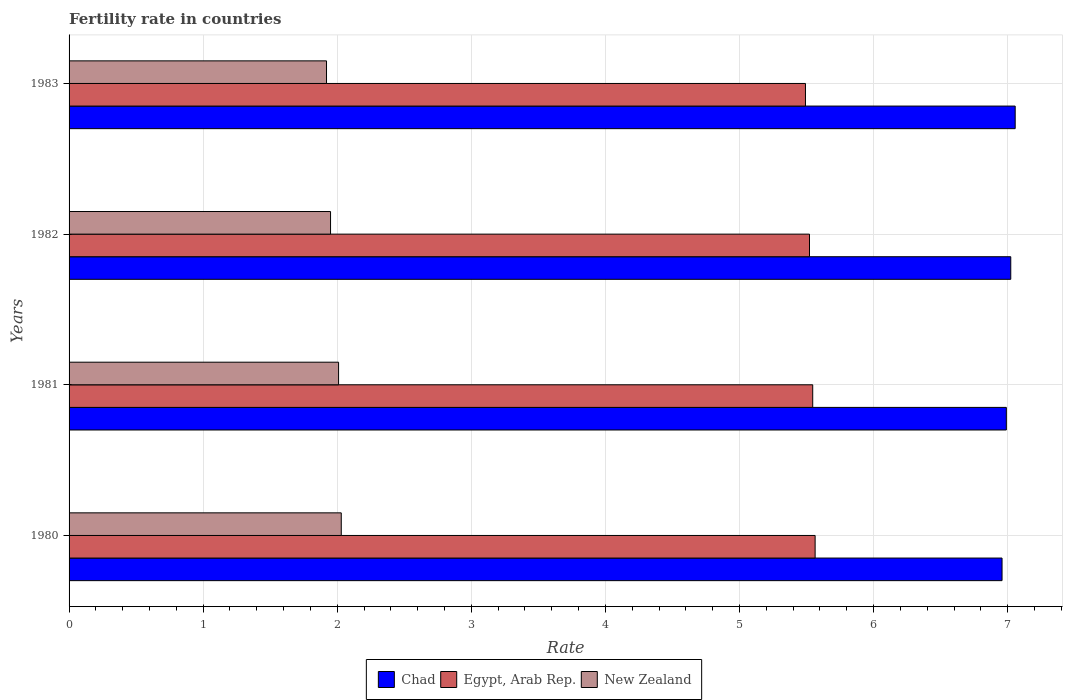How many different coloured bars are there?
Offer a very short reply. 3. How many groups of bars are there?
Offer a terse response. 4. Are the number of bars on each tick of the Y-axis equal?
Provide a short and direct response. Yes. What is the label of the 2nd group of bars from the top?
Your response must be concise. 1982. In how many cases, is the number of bars for a given year not equal to the number of legend labels?
Your answer should be very brief. 0. What is the fertility rate in New Zealand in 1981?
Make the answer very short. 2.01. Across all years, what is the maximum fertility rate in Egypt, Arab Rep.?
Your response must be concise. 5.56. Across all years, what is the minimum fertility rate in New Zealand?
Offer a terse response. 1.92. In which year was the fertility rate in Chad minimum?
Your answer should be very brief. 1980. What is the total fertility rate in Egypt, Arab Rep. in the graph?
Offer a very short reply. 22.12. What is the difference between the fertility rate in Chad in 1980 and that in 1981?
Offer a very short reply. -0.03. What is the difference between the fertility rate in New Zealand in 1981 and the fertility rate in Chad in 1982?
Make the answer very short. -5.01. What is the average fertility rate in New Zealand per year?
Ensure brevity in your answer.  1.98. In the year 1981, what is the difference between the fertility rate in Egypt, Arab Rep. and fertility rate in New Zealand?
Give a very brief answer. 3.54. What is the ratio of the fertility rate in New Zealand in 1982 to that in 1983?
Provide a short and direct response. 1.02. What is the difference between the highest and the second highest fertility rate in Chad?
Provide a succinct answer. 0.03. What is the difference between the highest and the lowest fertility rate in New Zealand?
Ensure brevity in your answer.  0.11. In how many years, is the fertility rate in Egypt, Arab Rep. greater than the average fertility rate in Egypt, Arab Rep. taken over all years?
Your answer should be very brief. 2. What does the 1st bar from the top in 1980 represents?
Provide a succinct answer. New Zealand. What does the 2nd bar from the bottom in 1980 represents?
Your response must be concise. Egypt, Arab Rep. Is it the case that in every year, the sum of the fertility rate in Chad and fertility rate in New Zealand is greater than the fertility rate in Egypt, Arab Rep.?
Your answer should be very brief. Yes. How many years are there in the graph?
Provide a succinct answer. 4. Does the graph contain grids?
Your answer should be compact. Yes. Where does the legend appear in the graph?
Your answer should be very brief. Bottom center. How many legend labels are there?
Give a very brief answer. 3. How are the legend labels stacked?
Ensure brevity in your answer.  Horizontal. What is the title of the graph?
Make the answer very short. Fertility rate in countries. Does "Latin America(developing only)" appear as one of the legend labels in the graph?
Provide a short and direct response. No. What is the label or title of the X-axis?
Your answer should be compact. Rate. What is the label or title of the Y-axis?
Provide a short and direct response. Years. What is the Rate of Chad in 1980?
Your answer should be compact. 6.96. What is the Rate in Egypt, Arab Rep. in 1980?
Offer a terse response. 5.56. What is the Rate of New Zealand in 1980?
Ensure brevity in your answer.  2.03. What is the Rate in Chad in 1981?
Offer a very short reply. 6.99. What is the Rate of Egypt, Arab Rep. in 1981?
Offer a very short reply. 5.55. What is the Rate in New Zealand in 1981?
Provide a short and direct response. 2.01. What is the Rate of Chad in 1982?
Your response must be concise. 7.02. What is the Rate of Egypt, Arab Rep. in 1982?
Keep it short and to the point. 5.52. What is the Rate of New Zealand in 1982?
Provide a succinct answer. 1.95. What is the Rate of Chad in 1983?
Provide a succinct answer. 7.06. What is the Rate of Egypt, Arab Rep. in 1983?
Your answer should be very brief. 5.49. What is the Rate in New Zealand in 1983?
Your response must be concise. 1.92. Across all years, what is the maximum Rate in Chad?
Provide a succinct answer. 7.06. Across all years, what is the maximum Rate in Egypt, Arab Rep.?
Offer a very short reply. 5.56. Across all years, what is the maximum Rate of New Zealand?
Your answer should be compact. 2.03. Across all years, what is the minimum Rate in Chad?
Make the answer very short. 6.96. Across all years, what is the minimum Rate of Egypt, Arab Rep.?
Your answer should be very brief. 5.49. Across all years, what is the minimum Rate in New Zealand?
Give a very brief answer. 1.92. What is the total Rate in Chad in the graph?
Make the answer very short. 28.03. What is the total Rate in Egypt, Arab Rep. in the graph?
Provide a short and direct response. 22.12. What is the total Rate in New Zealand in the graph?
Offer a very short reply. 7.91. What is the difference between the Rate of Chad in 1980 and that in 1981?
Your answer should be compact. -0.03. What is the difference between the Rate of Egypt, Arab Rep. in 1980 and that in 1981?
Provide a succinct answer. 0.02. What is the difference between the Rate in Chad in 1980 and that in 1982?
Give a very brief answer. -0.07. What is the difference between the Rate of Egypt, Arab Rep. in 1980 and that in 1982?
Your response must be concise. 0.04. What is the difference between the Rate in Chad in 1980 and that in 1983?
Provide a succinct answer. -0.1. What is the difference between the Rate of Egypt, Arab Rep. in 1980 and that in 1983?
Your response must be concise. 0.07. What is the difference between the Rate of New Zealand in 1980 and that in 1983?
Give a very brief answer. 0.11. What is the difference between the Rate in Chad in 1981 and that in 1982?
Your answer should be very brief. -0.03. What is the difference between the Rate in Egypt, Arab Rep. in 1981 and that in 1982?
Ensure brevity in your answer.  0.02. What is the difference between the Rate of Chad in 1981 and that in 1983?
Offer a terse response. -0.07. What is the difference between the Rate of Egypt, Arab Rep. in 1981 and that in 1983?
Your answer should be very brief. 0.05. What is the difference between the Rate of New Zealand in 1981 and that in 1983?
Offer a terse response. 0.09. What is the difference between the Rate in Chad in 1982 and that in 1983?
Your response must be concise. -0.03. What is the difference between the Rate in Egypt, Arab Rep. in 1982 and that in 1983?
Your answer should be very brief. 0.03. What is the difference between the Rate in New Zealand in 1982 and that in 1983?
Provide a short and direct response. 0.03. What is the difference between the Rate in Chad in 1980 and the Rate in Egypt, Arab Rep. in 1981?
Offer a terse response. 1.41. What is the difference between the Rate of Chad in 1980 and the Rate of New Zealand in 1981?
Offer a very short reply. 4.95. What is the difference between the Rate of Egypt, Arab Rep. in 1980 and the Rate of New Zealand in 1981?
Ensure brevity in your answer.  3.55. What is the difference between the Rate in Chad in 1980 and the Rate in Egypt, Arab Rep. in 1982?
Your answer should be very brief. 1.44. What is the difference between the Rate of Chad in 1980 and the Rate of New Zealand in 1982?
Give a very brief answer. 5.01. What is the difference between the Rate of Egypt, Arab Rep. in 1980 and the Rate of New Zealand in 1982?
Offer a very short reply. 3.61. What is the difference between the Rate in Chad in 1980 and the Rate in Egypt, Arab Rep. in 1983?
Offer a very short reply. 1.47. What is the difference between the Rate of Chad in 1980 and the Rate of New Zealand in 1983?
Your answer should be compact. 5.04. What is the difference between the Rate in Egypt, Arab Rep. in 1980 and the Rate in New Zealand in 1983?
Give a very brief answer. 3.64. What is the difference between the Rate in Chad in 1981 and the Rate in Egypt, Arab Rep. in 1982?
Offer a very short reply. 1.47. What is the difference between the Rate in Chad in 1981 and the Rate in New Zealand in 1982?
Offer a terse response. 5.04. What is the difference between the Rate in Egypt, Arab Rep. in 1981 and the Rate in New Zealand in 1982?
Keep it short and to the point. 3.6. What is the difference between the Rate of Chad in 1981 and the Rate of Egypt, Arab Rep. in 1983?
Offer a very short reply. 1.5. What is the difference between the Rate in Chad in 1981 and the Rate in New Zealand in 1983?
Provide a succinct answer. 5.07. What is the difference between the Rate in Egypt, Arab Rep. in 1981 and the Rate in New Zealand in 1983?
Offer a very short reply. 3.63. What is the difference between the Rate in Chad in 1982 and the Rate in Egypt, Arab Rep. in 1983?
Your answer should be compact. 1.53. What is the difference between the Rate of Chad in 1982 and the Rate of New Zealand in 1983?
Provide a succinct answer. 5.1. What is the difference between the Rate of Egypt, Arab Rep. in 1982 and the Rate of New Zealand in 1983?
Your answer should be compact. 3.6. What is the average Rate of Chad per year?
Offer a very short reply. 7.01. What is the average Rate in Egypt, Arab Rep. per year?
Ensure brevity in your answer.  5.53. What is the average Rate of New Zealand per year?
Ensure brevity in your answer.  1.98. In the year 1980, what is the difference between the Rate in Chad and Rate in Egypt, Arab Rep.?
Provide a succinct answer. 1.39. In the year 1980, what is the difference between the Rate of Chad and Rate of New Zealand?
Make the answer very short. 4.93. In the year 1980, what is the difference between the Rate of Egypt, Arab Rep. and Rate of New Zealand?
Provide a short and direct response. 3.53. In the year 1981, what is the difference between the Rate in Chad and Rate in Egypt, Arab Rep.?
Your response must be concise. 1.44. In the year 1981, what is the difference between the Rate in Chad and Rate in New Zealand?
Provide a short and direct response. 4.98. In the year 1981, what is the difference between the Rate of Egypt, Arab Rep. and Rate of New Zealand?
Give a very brief answer. 3.54. In the year 1982, what is the difference between the Rate in Chad and Rate in Egypt, Arab Rep.?
Ensure brevity in your answer.  1.5. In the year 1982, what is the difference between the Rate in Chad and Rate in New Zealand?
Offer a very short reply. 5.07. In the year 1982, what is the difference between the Rate in Egypt, Arab Rep. and Rate in New Zealand?
Make the answer very short. 3.57. In the year 1983, what is the difference between the Rate of Chad and Rate of Egypt, Arab Rep.?
Your answer should be compact. 1.56. In the year 1983, what is the difference between the Rate of Chad and Rate of New Zealand?
Keep it short and to the point. 5.14. In the year 1983, what is the difference between the Rate of Egypt, Arab Rep. and Rate of New Zealand?
Give a very brief answer. 3.57. What is the ratio of the Rate of Chad in 1980 to that in 1981?
Provide a short and direct response. 1. What is the ratio of the Rate in Chad in 1980 to that in 1982?
Offer a terse response. 0.99. What is the ratio of the Rate of Egypt, Arab Rep. in 1980 to that in 1982?
Your response must be concise. 1.01. What is the ratio of the Rate in New Zealand in 1980 to that in 1982?
Provide a short and direct response. 1.04. What is the ratio of the Rate of Chad in 1980 to that in 1983?
Your answer should be very brief. 0.99. What is the ratio of the Rate of Egypt, Arab Rep. in 1980 to that in 1983?
Your response must be concise. 1.01. What is the ratio of the Rate of New Zealand in 1980 to that in 1983?
Your response must be concise. 1.06. What is the ratio of the Rate in Chad in 1981 to that in 1982?
Make the answer very short. 1. What is the ratio of the Rate in New Zealand in 1981 to that in 1982?
Offer a very short reply. 1.03. What is the ratio of the Rate of Chad in 1981 to that in 1983?
Offer a very short reply. 0.99. What is the ratio of the Rate of Egypt, Arab Rep. in 1981 to that in 1983?
Ensure brevity in your answer.  1.01. What is the ratio of the Rate in New Zealand in 1981 to that in 1983?
Ensure brevity in your answer.  1.05. What is the ratio of the Rate of Egypt, Arab Rep. in 1982 to that in 1983?
Provide a short and direct response. 1.01. What is the ratio of the Rate of New Zealand in 1982 to that in 1983?
Offer a very short reply. 1.02. What is the difference between the highest and the second highest Rate in Chad?
Offer a terse response. 0.03. What is the difference between the highest and the second highest Rate of Egypt, Arab Rep.?
Keep it short and to the point. 0.02. What is the difference between the highest and the second highest Rate of New Zealand?
Ensure brevity in your answer.  0.02. What is the difference between the highest and the lowest Rate in Chad?
Offer a terse response. 0.1. What is the difference between the highest and the lowest Rate in Egypt, Arab Rep.?
Give a very brief answer. 0.07. What is the difference between the highest and the lowest Rate of New Zealand?
Your answer should be very brief. 0.11. 